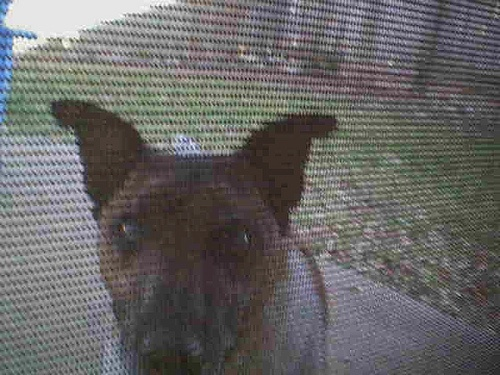Describe the objects in this image and their specific colors. I can see a dog in gray and black tones in this image. 